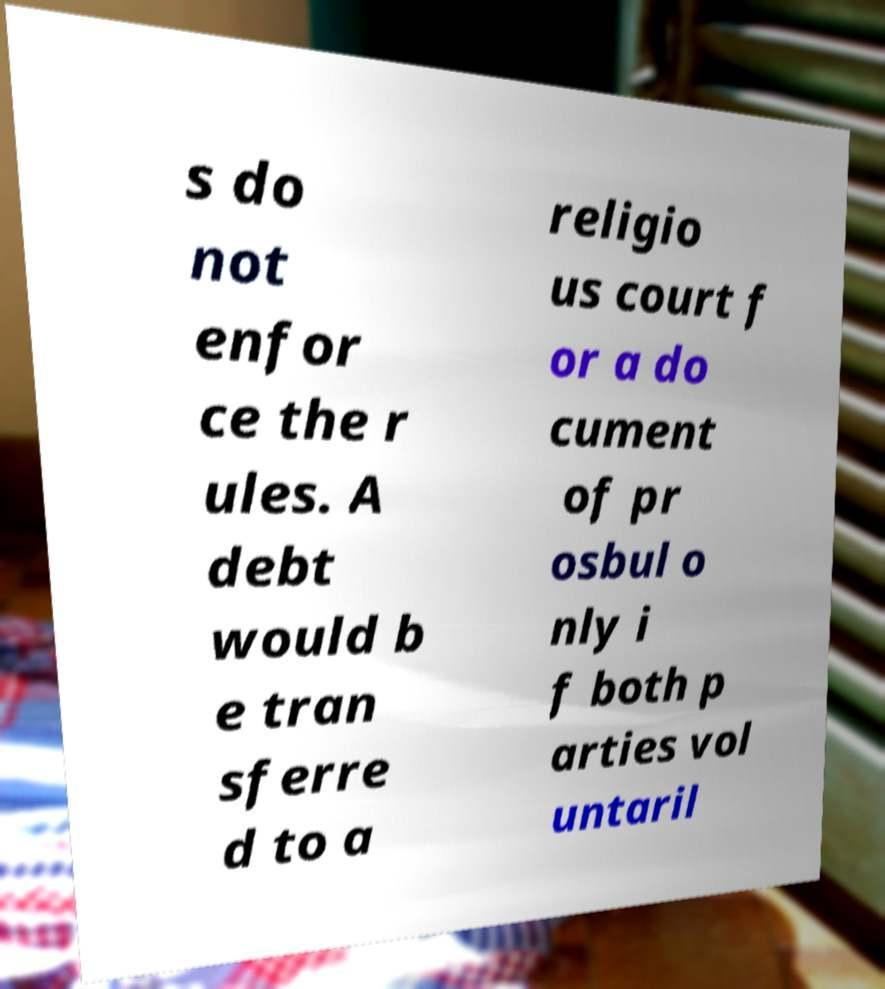Could you extract and type out the text from this image? s do not enfor ce the r ules. A debt would b e tran sferre d to a religio us court f or a do cument of pr osbul o nly i f both p arties vol untaril 